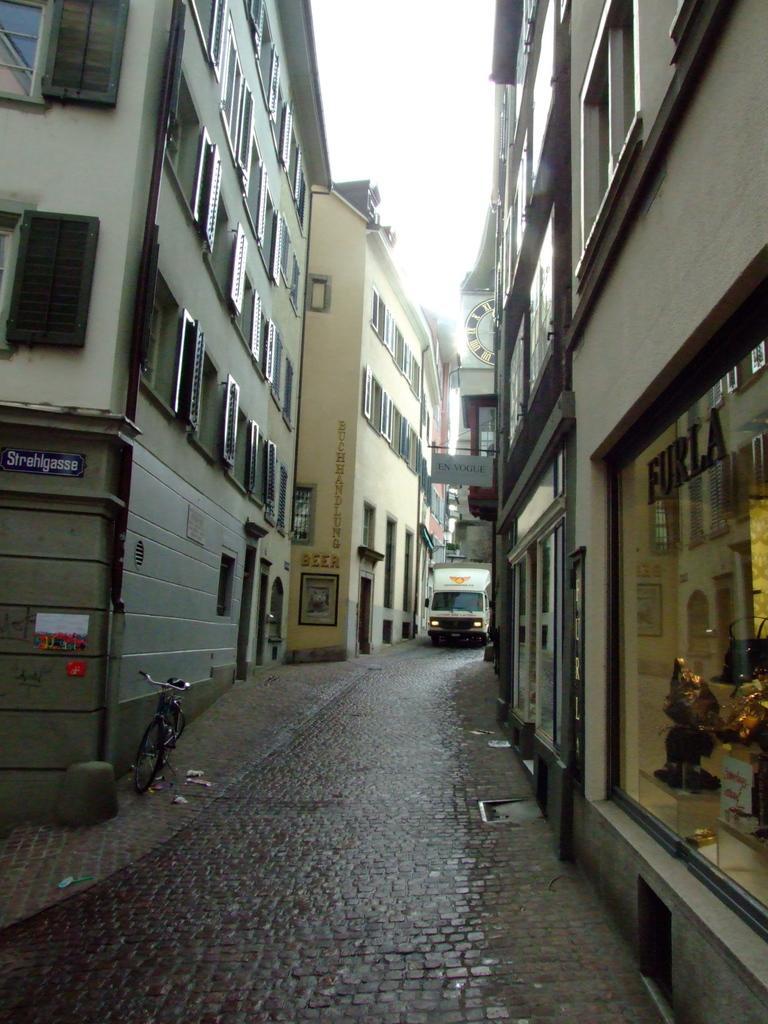Can you describe this image briefly? In the image we can see there are buildings and these are the windows of the buildings, in between there is a road and we can see the vehicle on the road and a bicycle. Here we can see the shop and the sky. 